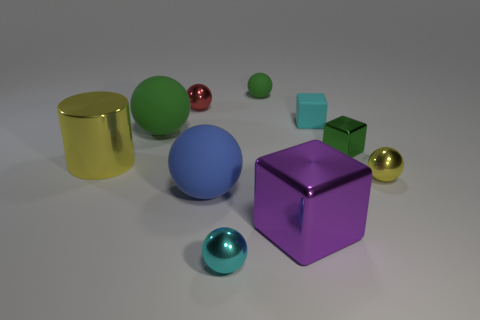How many blocks are green objects or yellow metal objects?
Make the answer very short. 1. Are there fewer red objects that are right of the cyan metal thing than small green rubber balls?
Make the answer very short. Yes. How many other things are made of the same material as the red object?
Make the answer very short. 5. Does the cyan matte object have the same size as the red thing?
Your answer should be compact. Yes. What number of things are tiny cyan things in front of the large blue matte sphere or cyan matte blocks?
Provide a succinct answer. 2. What is the sphere that is in front of the blue sphere behind the small cyan shiny thing made of?
Keep it short and to the point. Metal. Is there a small cyan rubber object of the same shape as the blue rubber object?
Ensure brevity in your answer.  No. Does the purple metallic object have the same size as the green matte sphere in front of the tiny green rubber ball?
Make the answer very short. Yes. What number of objects are big green objects left of the matte block or small spheres behind the big yellow metallic object?
Provide a short and direct response. 3. Is the number of tiny red objects right of the purple shiny object greater than the number of purple things?
Keep it short and to the point. No. 